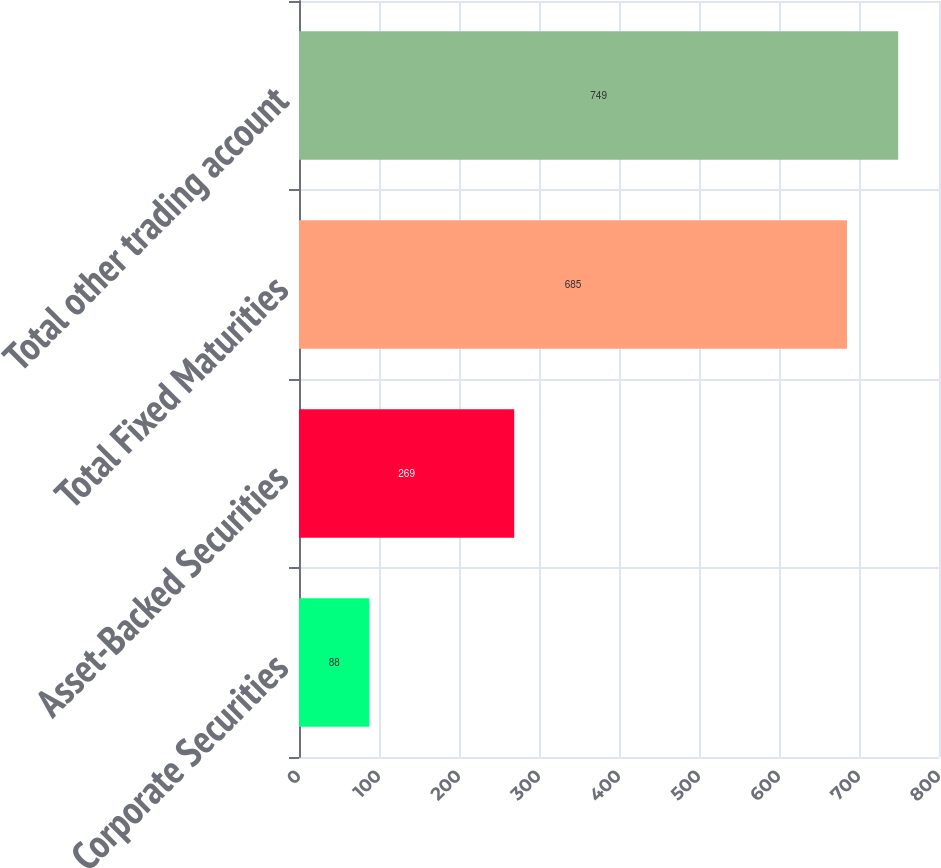Convert chart. <chart><loc_0><loc_0><loc_500><loc_500><bar_chart><fcel>Corporate Securities<fcel>Asset-Backed Securities<fcel>Total Fixed Maturities<fcel>Total other trading account<nl><fcel>88<fcel>269<fcel>685<fcel>749<nl></chart> 